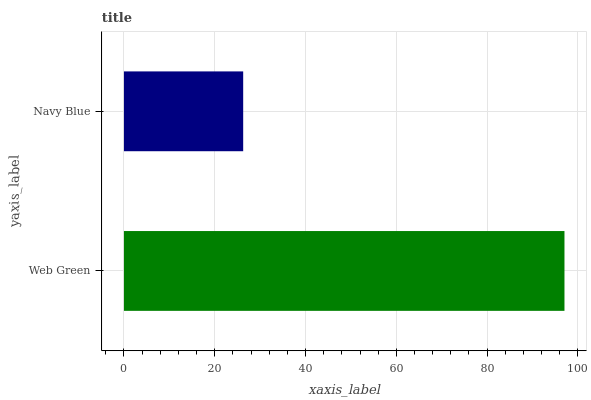Is Navy Blue the minimum?
Answer yes or no. Yes. Is Web Green the maximum?
Answer yes or no. Yes. Is Navy Blue the maximum?
Answer yes or no. No. Is Web Green greater than Navy Blue?
Answer yes or no. Yes. Is Navy Blue less than Web Green?
Answer yes or no. Yes. Is Navy Blue greater than Web Green?
Answer yes or no. No. Is Web Green less than Navy Blue?
Answer yes or no. No. Is Web Green the high median?
Answer yes or no. Yes. Is Navy Blue the low median?
Answer yes or no. Yes. Is Navy Blue the high median?
Answer yes or no. No. Is Web Green the low median?
Answer yes or no. No. 